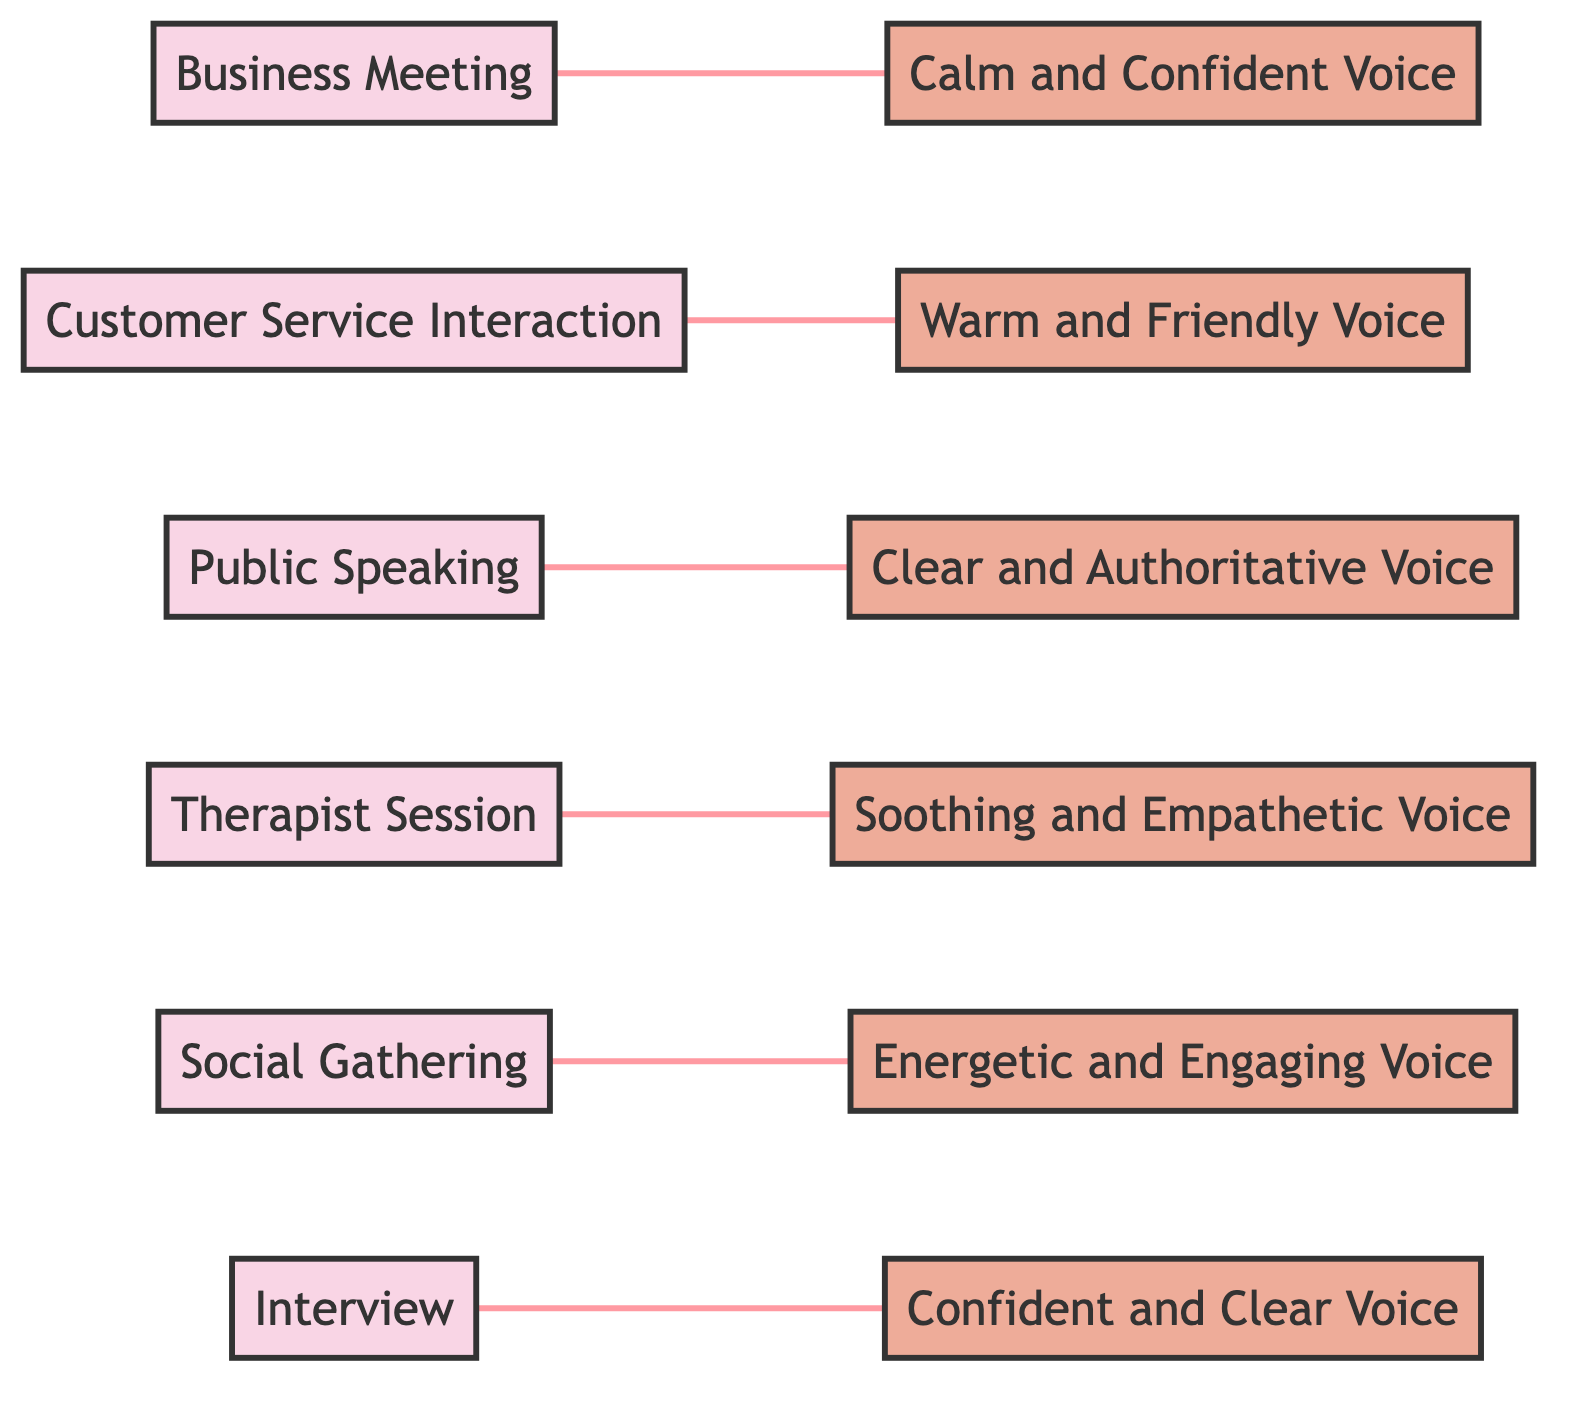What vocal quality is preferred in a Business Meeting? The diagram connects the "Business Meeting" node with the "Calm and Confident Voice" node, indicating that this is the preferred vocal quality for that social situation.
Answer: Calm and Confident Voice Which social situation is associated with a Warm and Friendly Voice? The "Customer Service Interaction" node is linked to the "Warm and Friendly Voice" node, showing this relationship clearly.
Answer: Customer Service Interaction How many nodes are present in the diagram? There are 12 nodes representing various social situations and preferred vocal qualities, as counted from the provided data.
Answer: 12 What is the common vocal quality preferred in Public Speaking? The edge links "Public Speaking" to the "Clear and Authoritative Voice," indicating this specific vocal quality for that situation.
Answer: Clear and Authoritative Voice Which voice type connects to the Social Gathering? The diagram shows that "Social Gathering" is linked to "Energetic and Engaging Voice," indicating a clear relationship between them.
Answer: Energetic and Engaging Voice What relationship is present between Therapist Session and Soothing and Empathetic Voice? The edge between "Therapist Session" and "Soothing and Empathetic Voice" indicates a direct connection, showcasing their association.
Answer: Direct connection Which social situation has the same vocal quality as an Interview? "Interview" is connected to "Confident and Clear Voice," treating them as linked situations over shared vocal quality requirements.
Answer: Confident and Clear Voice Is there any situation that connects to the Warm and Friendly Voice? The edge between "Customer Service Interaction" and "Warm and Friendly Voice" highlights this connection, allowing for an understanding of their relationship.
Answer: Yes What is the total number of edges in the diagram? The diagram shows a total of 6 edges, connecting various nodes as outlined in the provided data.
Answer: 6 